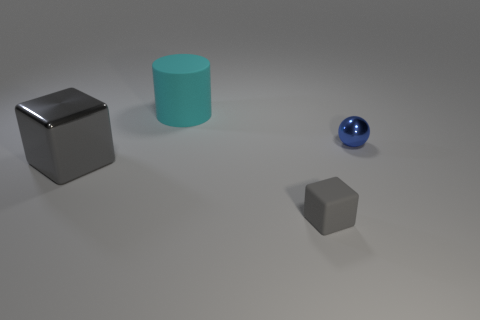Is there anything else that is made of the same material as the tiny blue ball?
Provide a short and direct response. Yes. The thing that is in front of the large cyan cylinder and behind the metal block is made of what material?
Offer a very short reply. Metal. How many gray metal objects are the same shape as the tiny rubber thing?
Offer a terse response. 1. What color is the big object that is to the right of the gray block that is behind the tiny gray block?
Provide a succinct answer. Cyan. Are there the same number of tiny gray blocks that are in front of the large rubber cylinder and large shiny blocks?
Provide a short and direct response. Yes. Is there a matte thing of the same size as the shiny ball?
Give a very brief answer. Yes. There is a ball; is its size the same as the object left of the large rubber object?
Your response must be concise. No. Is the number of big cyan rubber objects that are on the right side of the gray metal thing the same as the number of tiny rubber cubes that are behind the small gray cube?
Offer a terse response. No. There is a metallic object that is the same color as the small block; what is its shape?
Keep it short and to the point. Cube. There is a cube that is behind the tiny gray matte thing; what material is it?
Your response must be concise. Metal. 